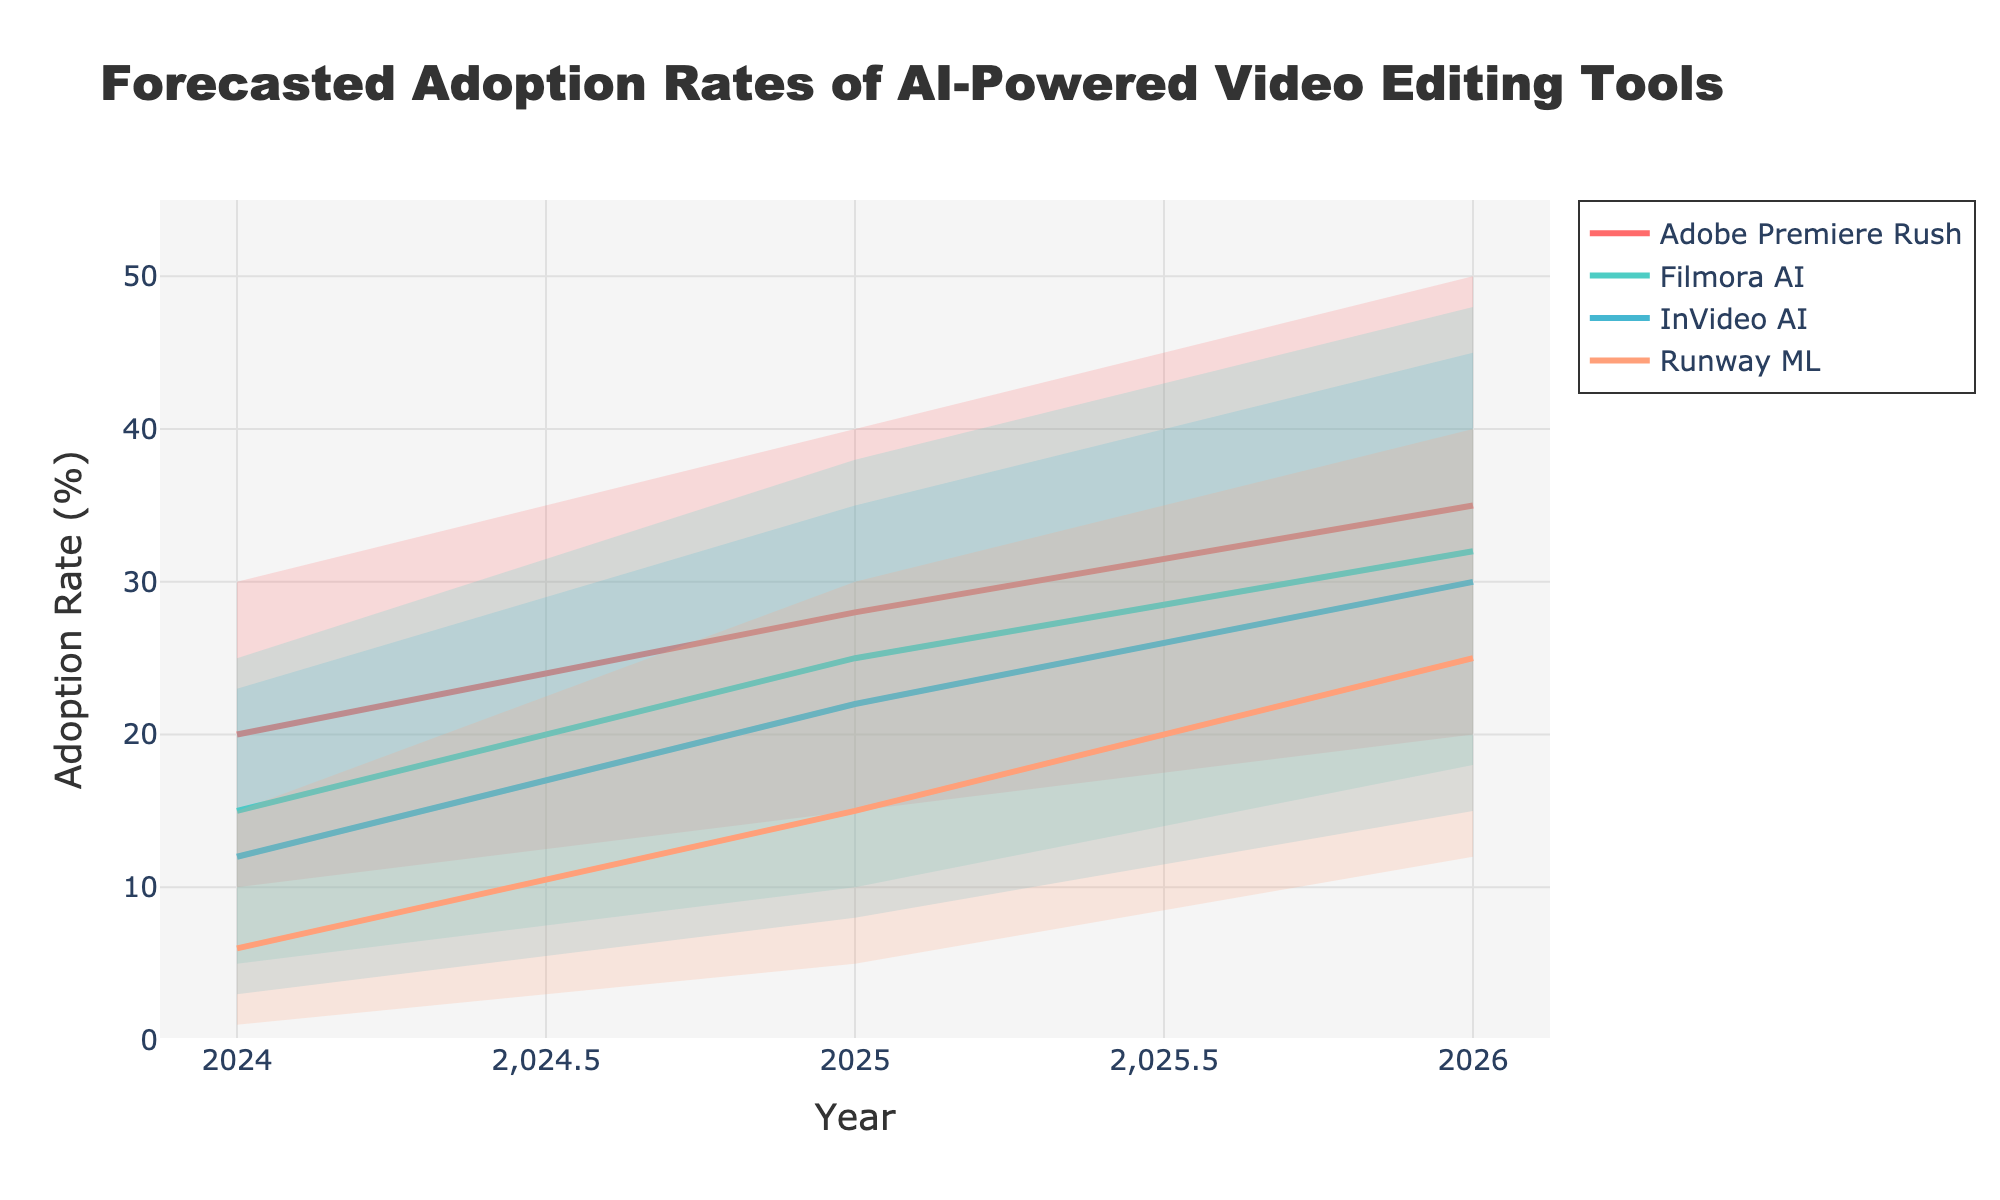What is the title of the chart? The title is often located at the top of the chart, presented in larger and bold text for emphasis. By reading the top portion of the chart, we can identify the title easily.
Answer: Forecasted Adoption Rates of AI-Powered Video Editing Tools How many AI-powered video editing tools are forecasted in the chart? By examining the legend or the lines/areas in different colors on the chart, we can count the distinct AI tools represented.
Answer: Four Which tool has the highest adoption rates in 2026 according to the mid-scenario forecast? Look at the mid-scenario forecast lines for each tool in 2026. Identify the tool with the highest y-axis value.
Answer: Adobe Premiere Rush How does the adoption rate of Runway ML change from 2024 to 2026 in the mid-scenario forecast? Examine the mid-scenario forecast lines for Runway ML in 2024 and 2026. Find the values and calculate the difference.
Answer: Increased by 19% Which tool shows the lowest high-range adoption rate in 2025? Check the top boundary of the shaded areas for each tool in 2025. Identify the tool with the lowest value along the y-axis.
Answer: Runway ML What is the difference between the high-range adoption rates of Adobe Premiere Rush and Filmora AI in 2026? Locate the high-range adoption rate for both tools in 2026, then subtract to find the difference.
Answer: 2% By how much is the expected adoption rate of InVideo AI higher in the mid-scenario forecast in 2026 compared to 2025? Check the mid-scenario forecast lines for InVideo AI in both 2025 and 2026, and subtract the 2025 value from the 2026 value.
Answer: 8% Which tool has the widest forecast range in 2025? For each tool, calculate the range (High - Low) in 2025, and compare these ranges to identify the largest one.
Answer: Adobe Premiere Rush Between Filmora AI and Runway ML, which tool's adoption rate increases more steeply from 2024 to 2026 in the mid-scenario? Look at the slope of the mid-scenario forecast lines from 2024 to 2026 for both tools, and compare their gradients.
Answer: Runway ML Does any tool show an overlapping forecast range with another tool in 2026? Check the shaded areas for any overlap across the different tools in 2026.
Answer: Yes 